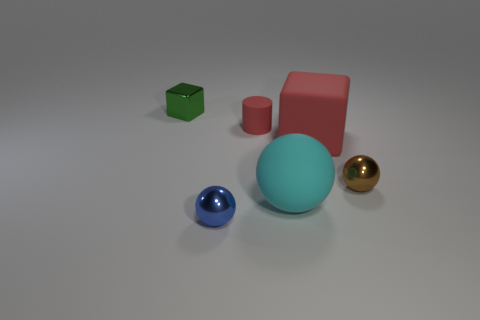Subtract all blue spheres. How many spheres are left? 2 Subtract all red cubes. How many cubes are left? 1 Subtract 2 spheres. How many spheres are left? 1 Subtract all purple cylinders. How many green cubes are left? 1 Subtract all cubes. Subtract all matte cylinders. How many objects are left? 3 Add 1 tiny metal objects. How many tiny metal objects are left? 4 Add 4 large red rubber cylinders. How many large red rubber cylinders exist? 4 Add 3 large cyan metal cubes. How many objects exist? 9 Subtract 1 green blocks. How many objects are left? 5 Subtract all cubes. How many objects are left? 4 